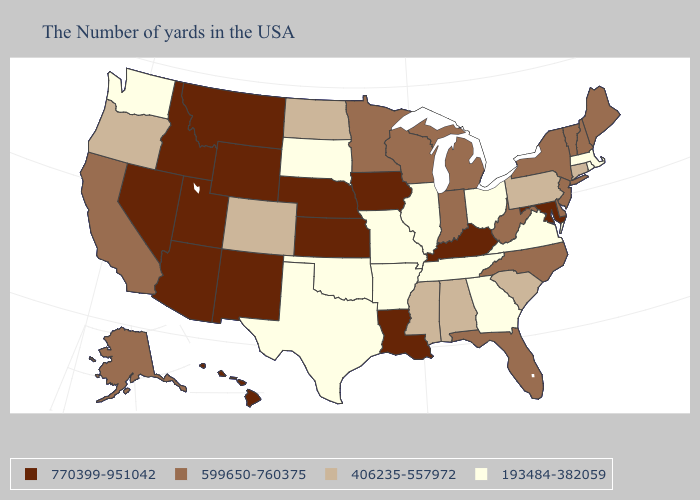Does the map have missing data?
Write a very short answer. No. What is the value of Iowa?
Keep it brief. 770399-951042. Name the states that have a value in the range 599650-760375?
Quick response, please. Maine, New Hampshire, Vermont, New York, New Jersey, Delaware, North Carolina, West Virginia, Florida, Michigan, Indiana, Wisconsin, Minnesota, California, Alaska. Among the states that border Utah , which have the highest value?
Keep it brief. Wyoming, New Mexico, Arizona, Idaho, Nevada. Is the legend a continuous bar?
Quick response, please. No. Does Ohio have the highest value in the MidWest?
Concise answer only. No. Name the states that have a value in the range 193484-382059?
Answer briefly. Massachusetts, Rhode Island, Virginia, Ohio, Georgia, Tennessee, Illinois, Missouri, Arkansas, Oklahoma, Texas, South Dakota, Washington. What is the lowest value in the MidWest?
Short answer required. 193484-382059. Name the states that have a value in the range 599650-760375?
Short answer required. Maine, New Hampshire, Vermont, New York, New Jersey, Delaware, North Carolina, West Virginia, Florida, Michigan, Indiana, Wisconsin, Minnesota, California, Alaska. What is the lowest value in the Northeast?
Be succinct. 193484-382059. Which states have the lowest value in the Northeast?
Short answer required. Massachusetts, Rhode Island. Name the states that have a value in the range 406235-557972?
Short answer required. Connecticut, Pennsylvania, South Carolina, Alabama, Mississippi, North Dakota, Colorado, Oregon. Name the states that have a value in the range 193484-382059?
Write a very short answer. Massachusetts, Rhode Island, Virginia, Ohio, Georgia, Tennessee, Illinois, Missouri, Arkansas, Oklahoma, Texas, South Dakota, Washington. Name the states that have a value in the range 406235-557972?
Quick response, please. Connecticut, Pennsylvania, South Carolina, Alabama, Mississippi, North Dakota, Colorado, Oregon. Does Minnesota have the same value as Idaho?
Be succinct. No. 